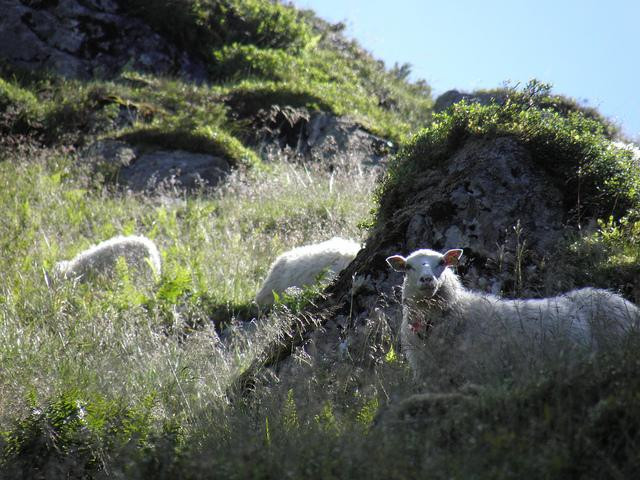What part of the animal on the right is visible?

Choices:
A) wings
B) tail
C) hooves
D) ears ears 